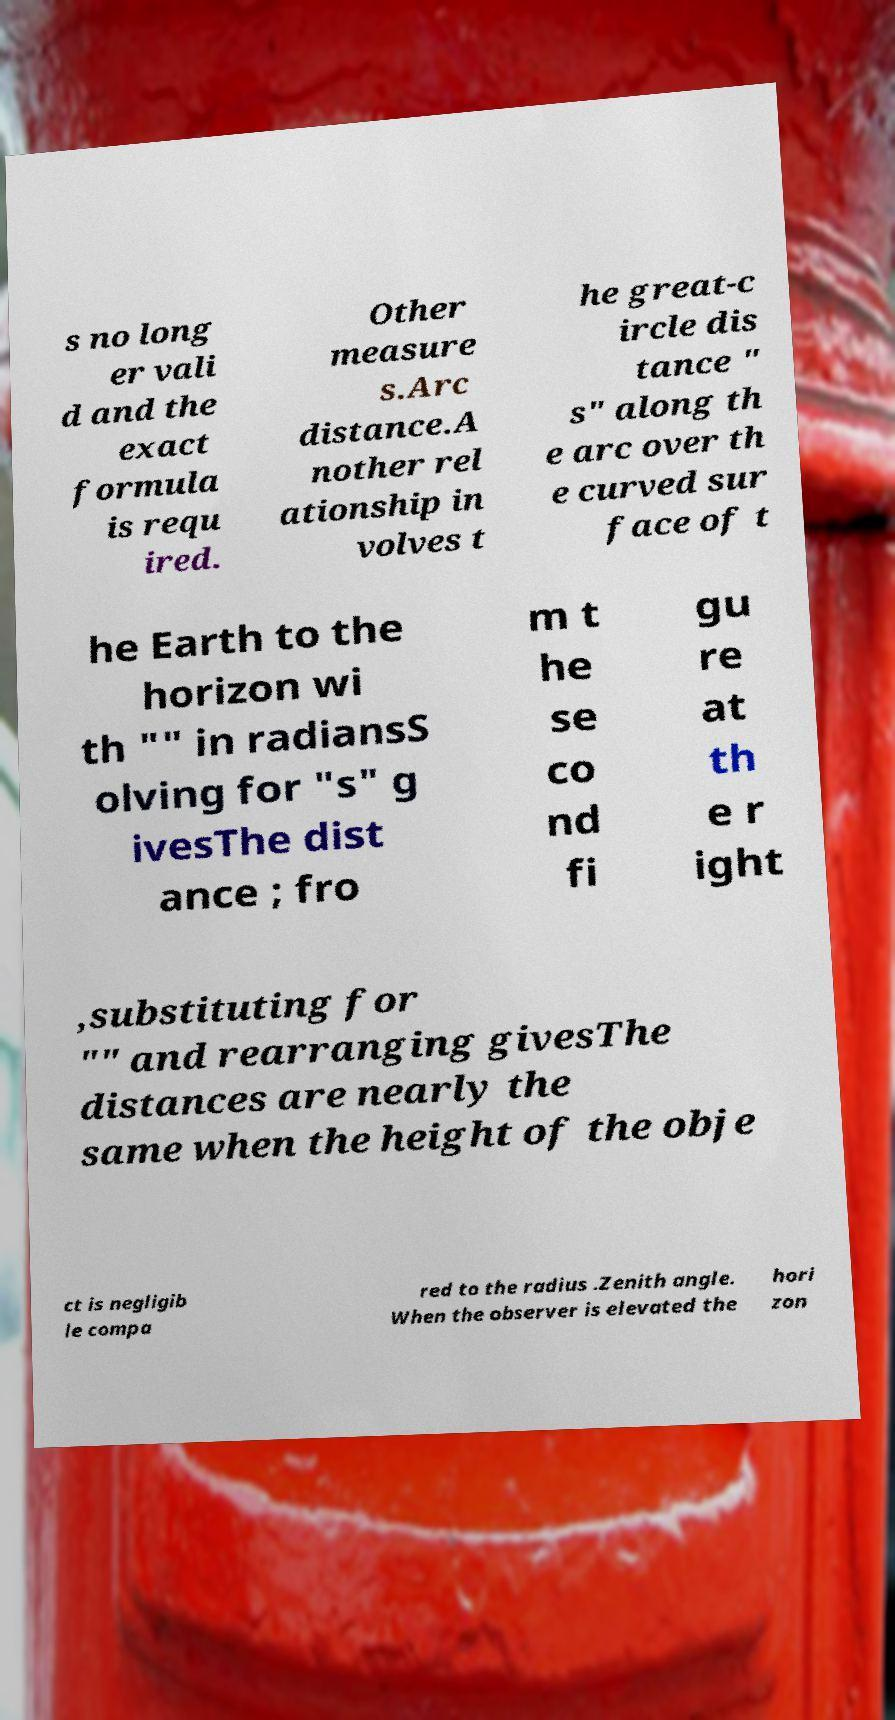Please identify and transcribe the text found in this image. s no long er vali d and the exact formula is requ ired. Other measure s.Arc distance.A nother rel ationship in volves t he great-c ircle dis tance " s" along th e arc over th e curved sur face of t he Earth to the horizon wi th "" in radiansS olving for "s" g ivesThe dist ance ; fro m t he se co nd fi gu re at th e r ight ,substituting for "" and rearranging givesThe distances are nearly the same when the height of the obje ct is negligib le compa red to the radius .Zenith angle. When the observer is elevated the hori zon 